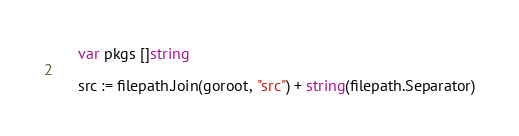Convert code to text. <code><loc_0><loc_0><loc_500><loc_500><_Go_>	var pkgs []string

	src := filepath.Join(goroot, "src") + string(filepath.Separator)</code> 